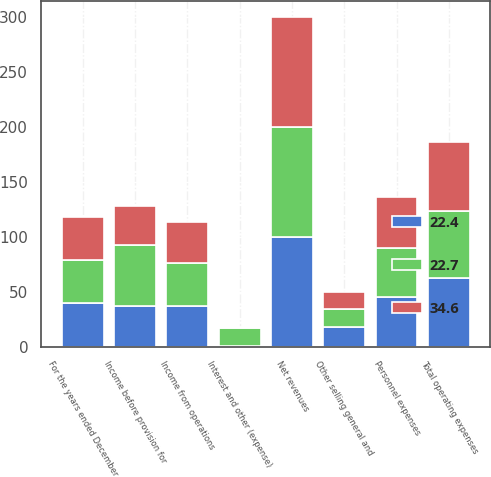<chart> <loc_0><loc_0><loc_500><loc_500><stacked_bar_chart><ecel><fcel>For the years ended December<fcel>Net revenues<fcel>Personnel expenses<fcel>Other selling general and<fcel>Total operating expenses<fcel>Income from operations<fcel>Interest and other (expense)<fcel>Income before provision for<nl><fcel>34.6<fcel>39.3<fcel>100<fcel>46.8<fcel>15.9<fcel>62.7<fcel>37.3<fcel>1.2<fcel>36<nl><fcel>22.4<fcel>39.3<fcel>100<fcel>45<fcel>17.8<fcel>62.8<fcel>37.2<fcel>0.5<fcel>36.7<nl><fcel>22.7<fcel>39.3<fcel>100<fcel>44.6<fcel>16.1<fcel>60.7<fcel>39.3<fcel>16.5<fcel>55.8<nl></chart> 